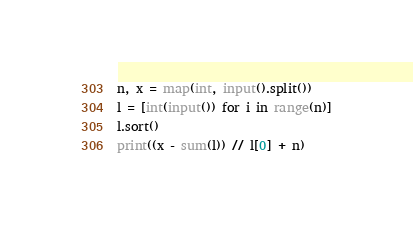Convert code to text. <code><loc_0><loc_0><loc_500><loc_500><_Python_>n, x = map(int, input().split())
l = [int(input()) for i in range(n)]
l.sort()
print((x - sum(l)) // l[0] + n)</code> 